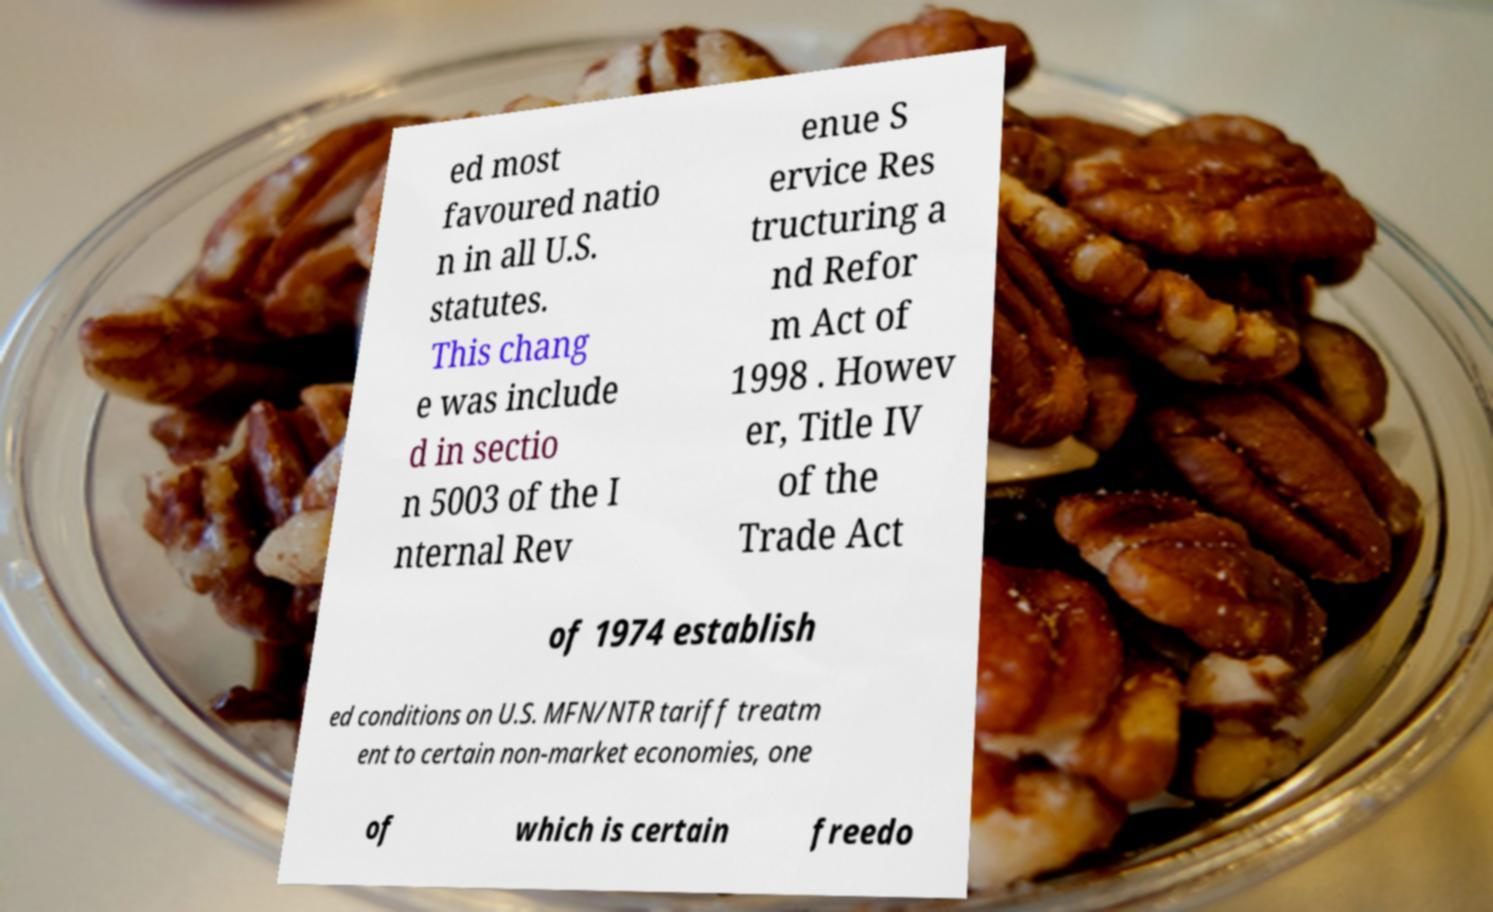Could you extract and type out the text from this image? ed most favoured natio n in all U.S. statutes. This chang e was include d in sectio n 5003 of the I nternal Rev enue S ervice Res tructuring a nd Refor m Act of 1998 . Howev er, Title IV of the Trade Act of 1974 establish ed conditions on U.S. MFN/NTR tariff treatm ent to certain non-market economies, one of which is certain freedo 